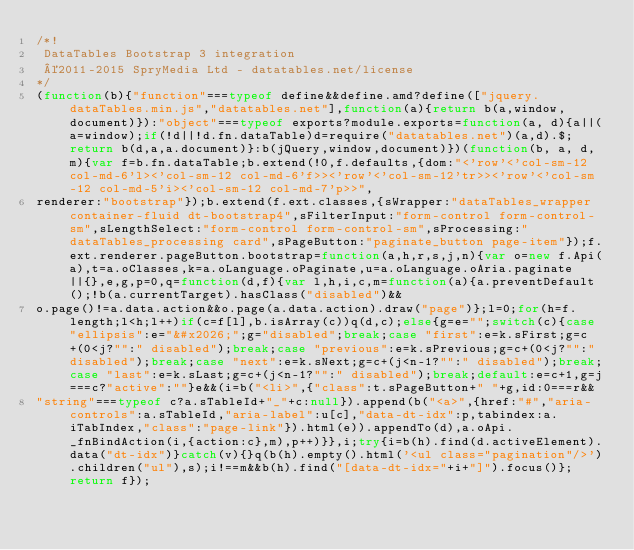Convert code to text. <code><loc_0><loc_0><loc_500><loc_500><_JavaScript_>/*!
 DataTables Bootstrap 3 integration
 ©2011-2015 SpryMedia Ltd - datatables.net/license
*/
(function(b){"function"===typeof define&&define.amd?define(["jquery.dataTables.min.js","datatables.net"],function(a){return b(a,window,document)}):"object"===typeof exports?module.exports=function(a, d){a||(a=window);if(!d||!d.fn.dataTable)d=require("datatables.net")(a,d).$;return b(d,a,a.document)}:b(jQuery,window,document)})(function(b, a, d, m){var f=b.fn.dataTable;b.extend(!0,f.defaults,{dom:"<'row'<'col-sm-12 col-md-6'l><'col-sm-12 col-md-6'f>><'row'<'col-sm-12'tr>><'row'<'col-sm-12 col-md-5'i><'col-sm-12 col-md-7'p>>",
renderer:"bootstrap"});b.extend(f.ext.classes,{sWrapper:"dataTables_wrapper container-fluid dt-bootstrap4",sFilterInput:"form-control form-control-sm",sLengthSelect:"form-control form-control-sm",sProcessing:"dataTables_processing card",sPageButton:"paginate_button page-item"});f.ext.renderer.pageButton.bootstrap=function(a,h,r,s,j,n){var o=new f.Api(a),t=a.oClasses,k=a.oLanguage.oPaginate,u=a.oLanguage.oAria.paginate||{},e,g,p=0,q=function(d,f){var l,h,i,c,m=function(a){a.preventDefault();!b(a.currentTarget).hasClass("disabled")&&
o.page()!=a.data.action&&o.page(a.data.action).draw("page")};l=0;for(h=f.length;l<h;l++)if(c=f[l],b.isArray(c))q(d,c);else{g=e="";switch(c){case "ellipsis":e="&#x2026;";g="disabled";break;case "first":e=k.sFirst;g=c+(0<j?"":" disabled");break;case "previous":e=k.sPrevious;g=c+(0<j?"":" disabled");break;case "next":e=k.sNext;g=c+(j<n-1?"":" disabled");break;case "last":e=k.sLast;g=c+(j<n-1?"":" disabled");break;default:e=c+1,g=j===c?"active":""}e&&(i=b("<li>",{"class":t.sPageButton+" "+g,id:0===r&&
"string"===typeof c?a.sTableId+"_"+c:null}).append(b("<a>",{href:"#","aria-controls":a.sTableId,"aria-label":u[c],"data-dt-idx":p,tabindex:a.iTabIndex,"class":"page-link"}).html(e)).appendTo(d),a.oApi._fnBindAction(i,{action:c},m),p++)}},i;try{i=b(h).find(d.activeElement).data("dt-idx")}catch(v){}q(b(h).empty().html('<ul class="pagination"/>').children("ul"),s);i!==m&&b(h).find("[data-dt-idx="+i+"]").focus()};return f});</code> 